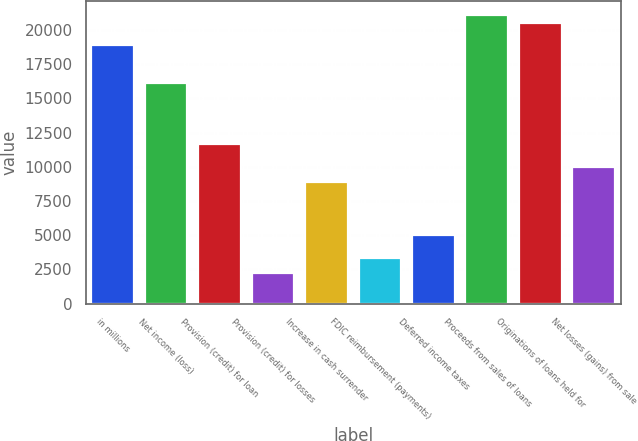<chart> <loc_0><loc_0><loc_500><loc_500><bar_chart><fcel>in millions<fcel>Net income (loss)<fcel>Provision (credit) for loan<fcel>Provision (credit) for losses<fcel>Increase in cash surrender<fcel>FDIC reimbursement (payments)<fcel>Deferred income taxes<fcel>Proceeds from sales of loans<fcel>Originations of loans held for<fcel>Net losses (gains) from sale<nl><fcel>18871<fcel>16096<fcel>11656<fcel>2221<fcel>8881<fcel>3331<fcel>4996<fcel>21091<fcel>20536<fcel>9991<nl></chart> 